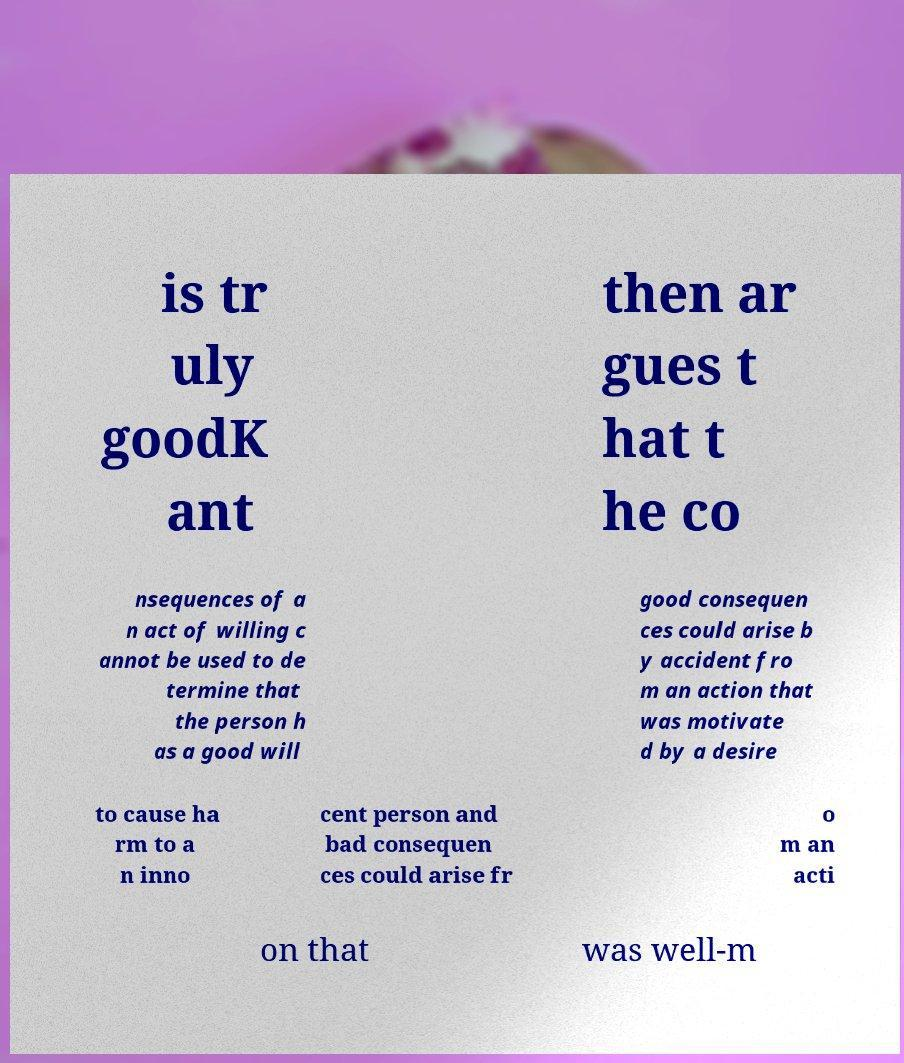Can you accurately transcribe the text from the provided image for me? is tr uly goodK ant then ar gues t hat t he co nsequences of a n act of willing c annot be used to de termine that the person h as a good will good consequen ces could arise b y accident fro m an action that was motivate d by a desire to cause ha rm to a n inno cent person and bad consequen ces could arise fr o m an acti on that was well-m 